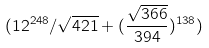<formula> <loc_0><loc_0><loc_500><loc_500>( 1 2 ^ { 2 4 8 } / \sqrt { 4 2 1 } + ( \frac { \sqrt { 3 6 6 } } { 3 9 4 } ) ^ { 1 3 8 } )</formula> 